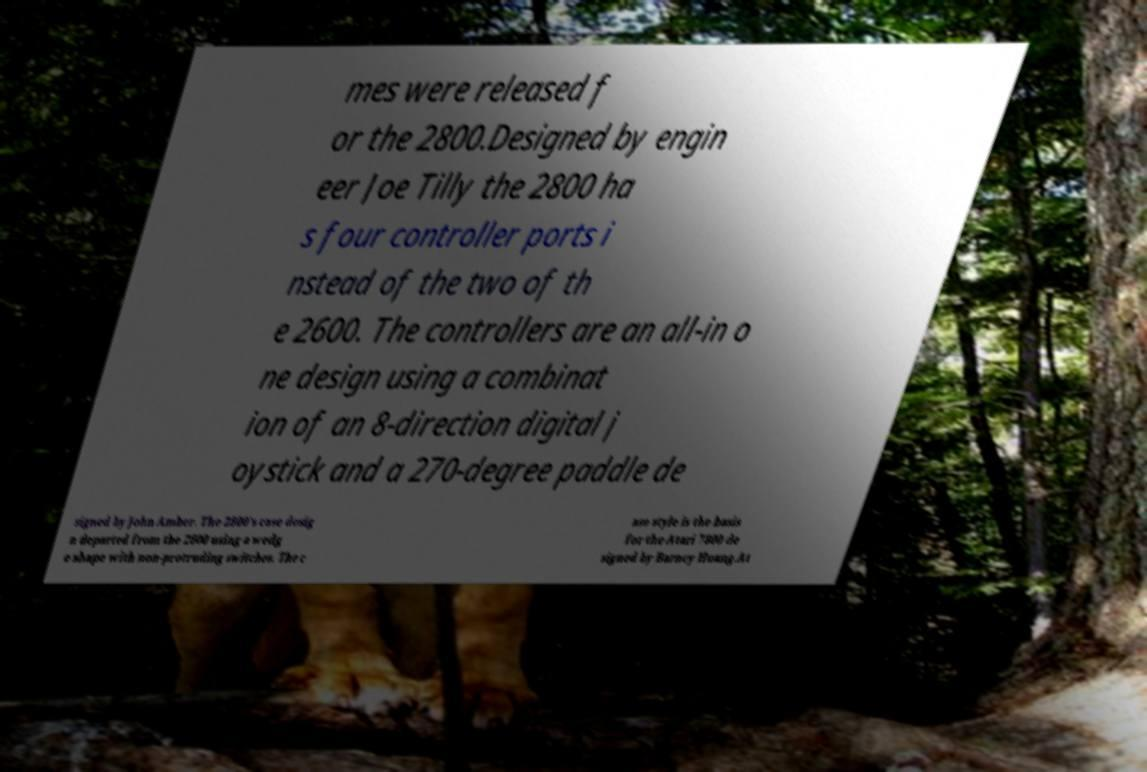Could you extract and type out the text from this image? mes were released f or the 2800.Designed by engin eer Joe Tilly the 2800 ha s four controller ports i nstead of the two of th e 2600. The controllers are an all-in o ne design using a combinat ion of an 8-direction digital j oystick and a 270-degree paddle de signed by John Amber. The 2800's case desig n departed from the 2600 using a wedg e shape with non-protruding switches. The c ase style is the basis for the Atari 7800 de signed by Barney Huang.At 